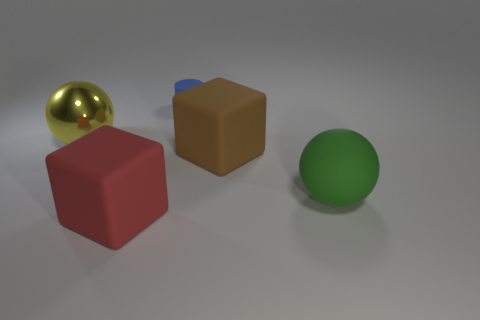Add 5 large blue shiny cylinders. How many objects exist? 10 Subtract all cylinders. How many objects are left? 4 Subtract all matte cylinders. Subtract all green rubber objects. How many objects are left? 3 Add 1 big metal spheres. How many big metal spheres are left? 2 Add 2 gray shiny balls. How many gray shiny balls exist? 2 Subtract 0 brown balls. How many objects are left? 5 